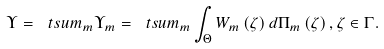<formula> <loc_0><loc_0><loc_500><loc_500>\Upsilon = \ t s u m _ { m } \Upsilon _ { m } = \ t s u m _ { m } \int _ { \Theta } W _ { m } \left ( \zeta \right ) d \Pi _ { m } \left ( \zeta \right ) , \zeta \in \Gamma .</formula> 